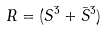<formula> <loc_0><loc_0><loc_500><loc_500>R = ( S ^ { 3 } + { \bar { S } } ^ { 3 } )</formula> 